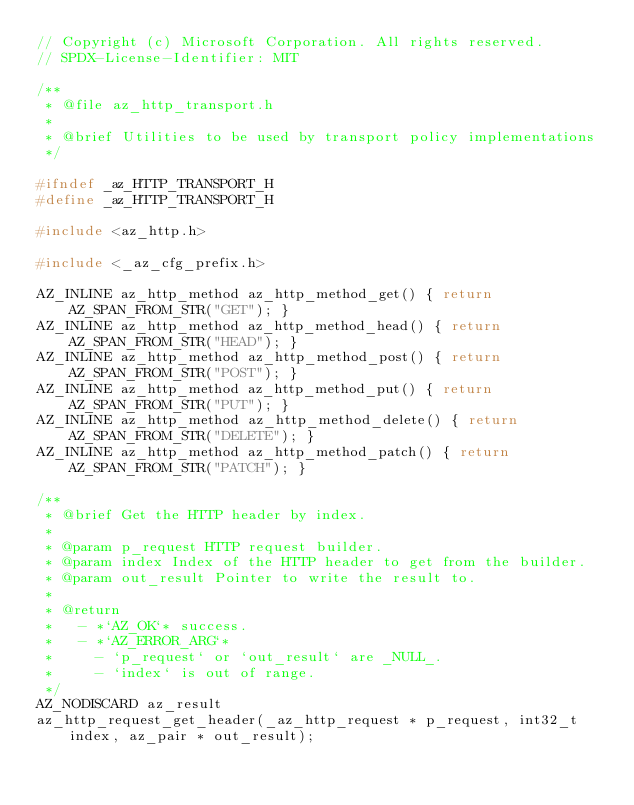Convert code to text. <code><loc_0><loc_0><loc_500><loc_500><_C_>// Copyright (c) Microsoft Corporation. All rights reserved.
// SPDX-License-Identifier: MIT

/**
 * @file az_http_transport.h
 *
 * @brief Utilities to be used by transport policy implementations
 */

#ifndef _az_HTTP_TRANSPORT_H
#define _az_HTTP_TRANSPORT_H

#include <az_http.h>

#include <_az_cfg_prefix.h>

AZ_INLINE az_http_method az_http_method_get() { return AZ_SPAN_FROM_STR("GET"); }
AZ_INLINE az_http_method az_http_method_head() { return AZ_SPAN_FROM_STR("HEAD"); }
AZ_INLINE az_http_method az_http_method_post() { return AZ_SPAN_FROM_STR("POST"); }
AZ_INLINE az_http_method az_http_method_put() { return AZ_SPAN_FROM_STR("PUT"); }
AZ_INLINE az_http_method az_http_method_delete() { return AZ_SPAN_FROM_STR("DELETE"); }
AZ_INLINE az_http_method az_http_method_patch() { return AZ_SPAN_FROM_STR("PATCH"); }

/**
 * @brief Get the HTTP header by index.
 *
 * @param p_request HTTP request builder.
 * @param index Index of the HTTP header to get from the builder.
 * @param out_result Pointer to write the result to.
 *
 * @return
 *   - *`AZ_OK`* success.
 *   - *`AZ_ERROR_ARG`*
 *     - `p_request` or `out_result` are _NULL_.
 *     - `index` is out of range.
 */
AZ_NODISCARD az_result
az_http_request_get_header(_az_http_request * p_request, int32_t index, az_pair * out_result);
</code> 